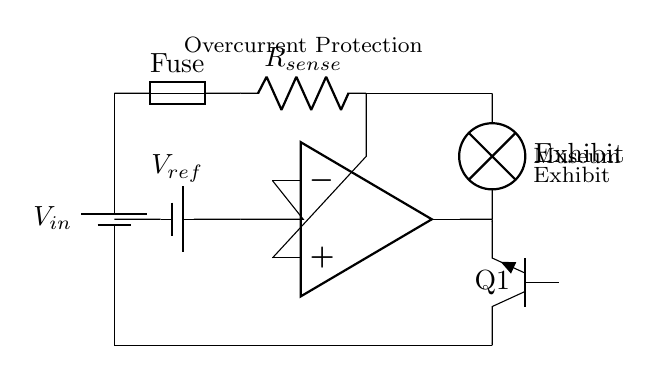What is the type of power source used? The power source is a battery, indicated by the symbol used in the circuit diagram.
Answer: battery What component is used for current sensing? The component used for current sensing in this circuit is a resistor labeled as R sense.
Answer: R sense What is the function of the fuse in this circuit? The fuse is used to protect the circuit by blowing if the current exceeds a certain level, hence protecting downstream components.
Answer: current protection What does the operational amplifier do in this circuit? The operational amplifier, indicated in the circuit, is used to control the output based on the comparison of the sensed current and the reference voltage.
Answer: control output What is the reference voltage in this circuit? The reference voltage is provided by the battery labeled as V ref, which supplies a fixed voltage for comparison in the operational amplifier.
Answer: V ref Why is the transistor labeled Q1 used in this circuit? The transistor Q1 functions as a switch that is activated when the operational amplifier output indicates that the sensed current is too high, thus protecting the load.
Answer: switch for protection What type of load is connected in this circuit? The load connected in this circuit is an exhibit lamp, indicated by the symbol used, showcasing the powered exhibit in the museum.
Answer: exhibit lamp 